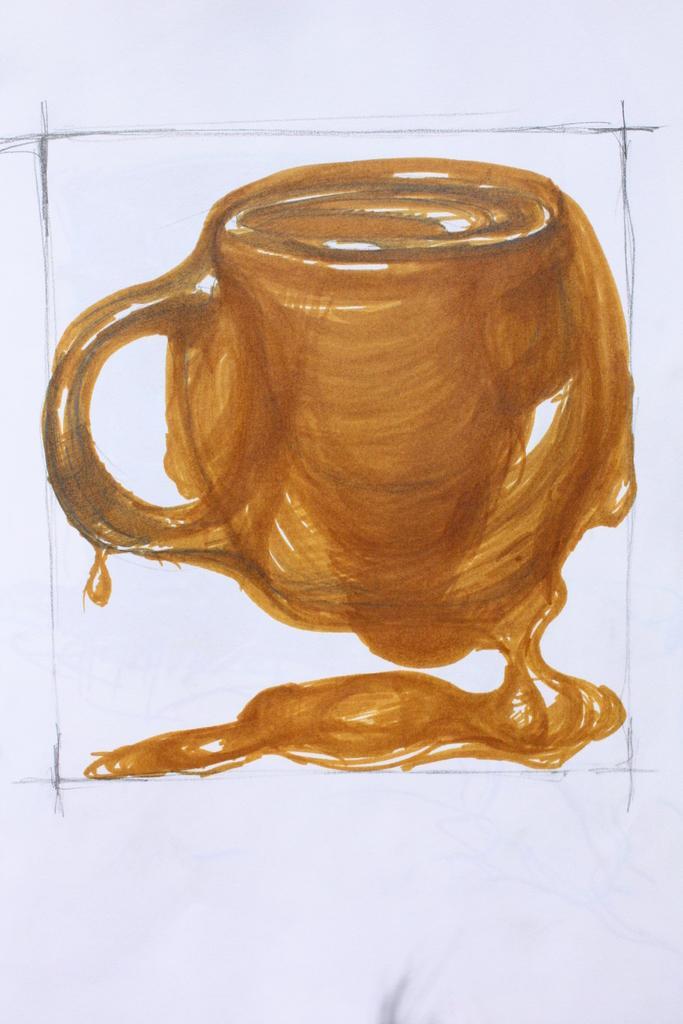How would you summarize this image in a sentence or two? This is a drawing of cup, this is white color. 